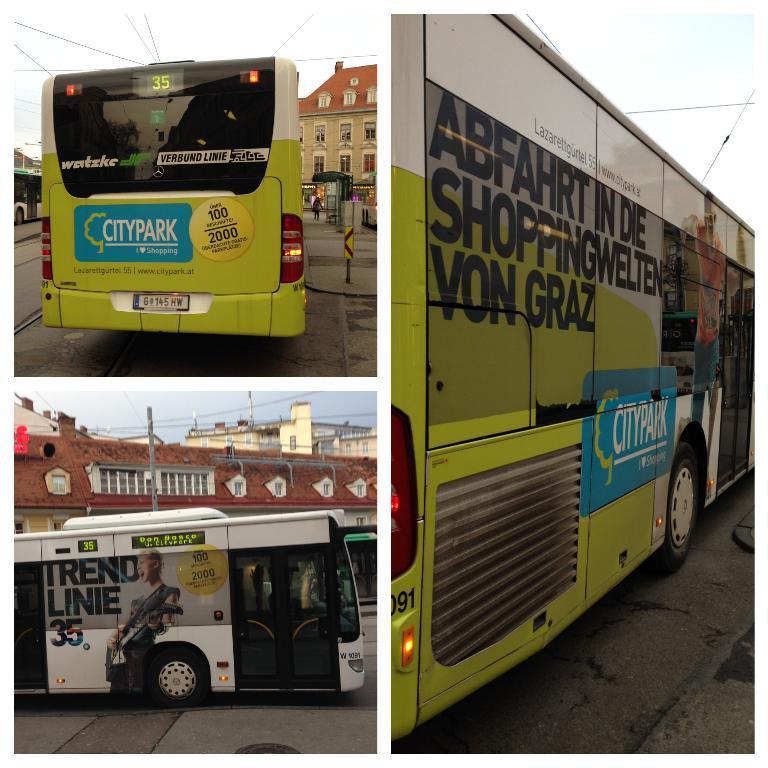Please provide a concise description of this image. In this image I can see a bus which is green, blue, black and white in color on the road. In the background I can see a building, a pole, few wires and the sky. 